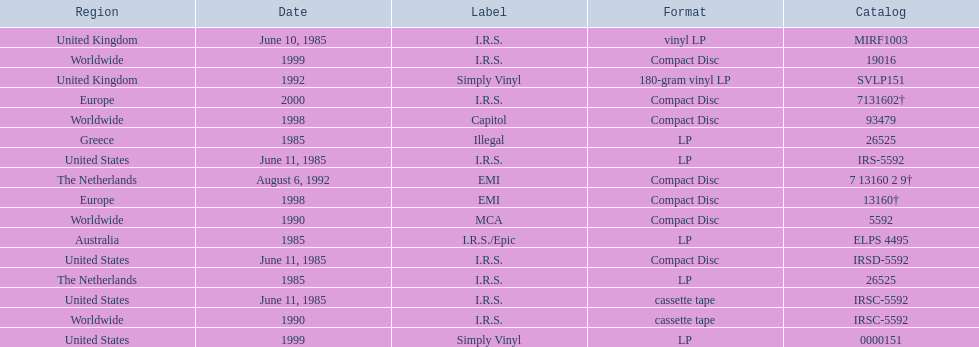What dates were lps of any kind released? June 10, 1985, June 11, 1985, 1985, 1985, 1985, 1992, 1999. In which countries were these released in by i.r.s.? United Kingdom, United States, Australia, The Netherlands. Which of these countries is not in the northern hemisphere? Australia. 